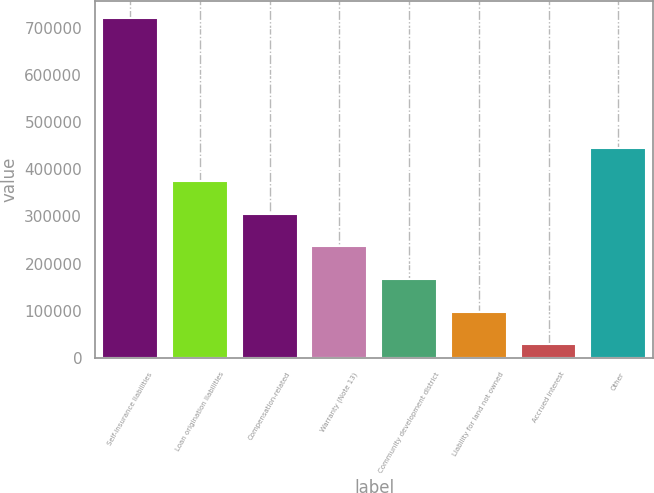<chart> <loc_0><loc_0><loc_500><loc_500><bar_chart><fcel>Self-insurance liabilities<fcel>Loan origination liabilities<fcel>Compensation-related<fcel>Warranty (Note 13)<fcel>Community development district<fcel>Liability for land not owned<fcel>Accrued interest<fcel>Other<nl><fcel>721284<fcel>374998<fcel>305741<fcel>236484<fcel>167227<fcel>97970.1<fcel>28713<fcel>444256<nl></chart> 